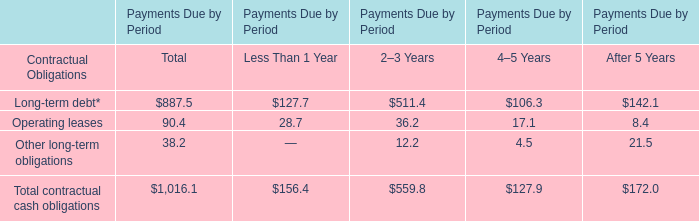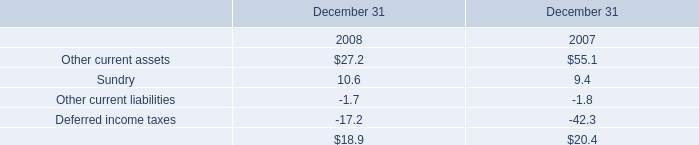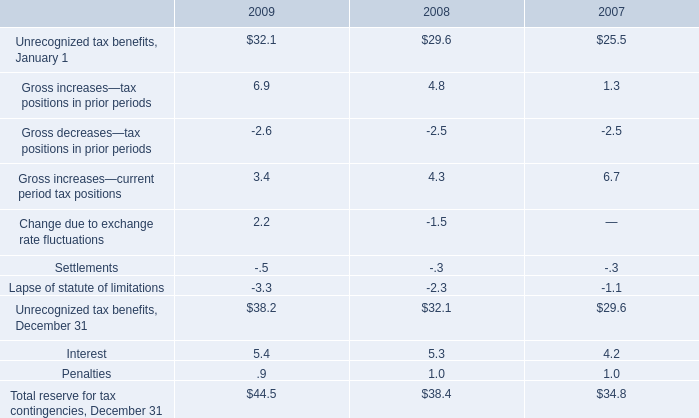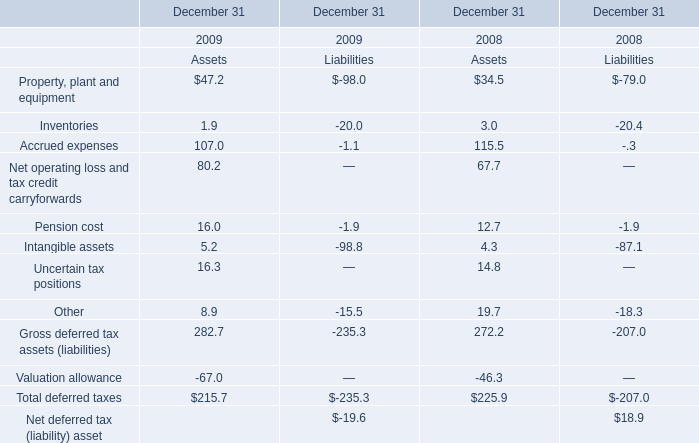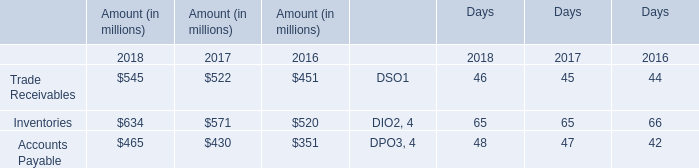What was the average value of the Interest in the years where Gross increases—current period tax positions is positive? (in million) 
Computations: (((5.4 + 5.3) + 4.2) / 3)
Answer: 4.96667. 